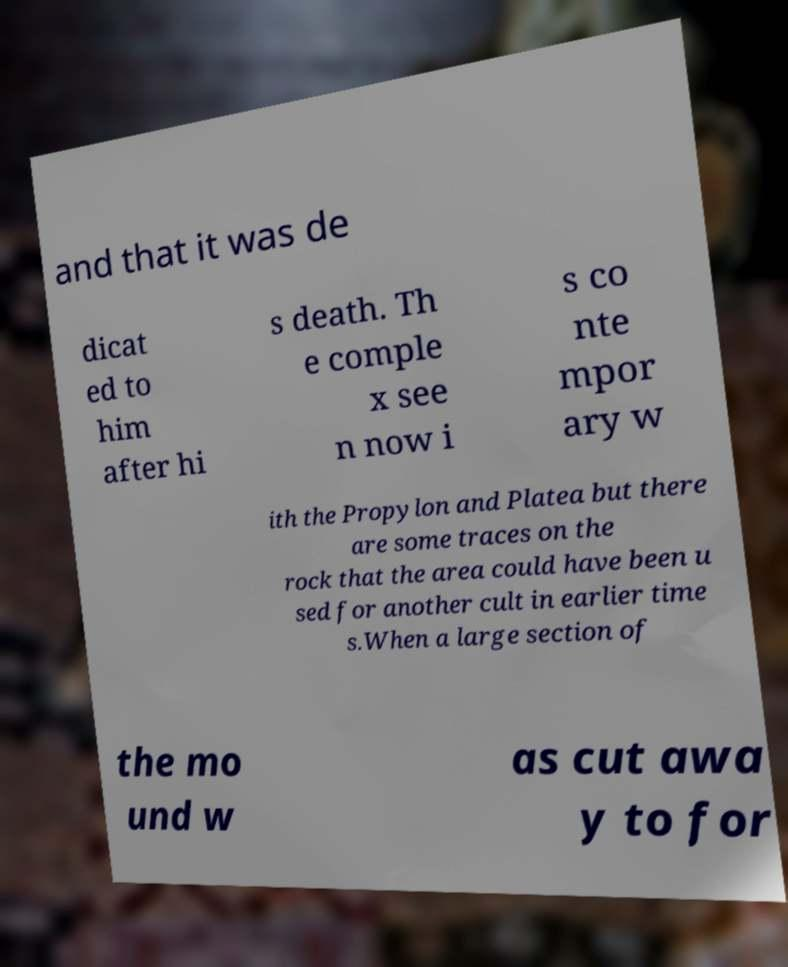Could you extract and type out the text from this image? and that it was de dicat ed to him after hi s death. Th e comple x see n now i s co nte mpor ary w ith the Propylon and Platea but there are some traces on the rock that the area could have been u sed for another cult in earlier time s.When a large section of the mo und w as cut awa y to for 